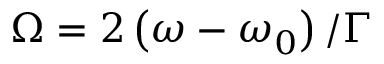Convert formula to latex. <formula><loc_0><loc_0><loc_500><loc_500>\Omega = { 2 } \left ( \omega - \omega _ { 0 } \right ) / \Gamma</formula> 